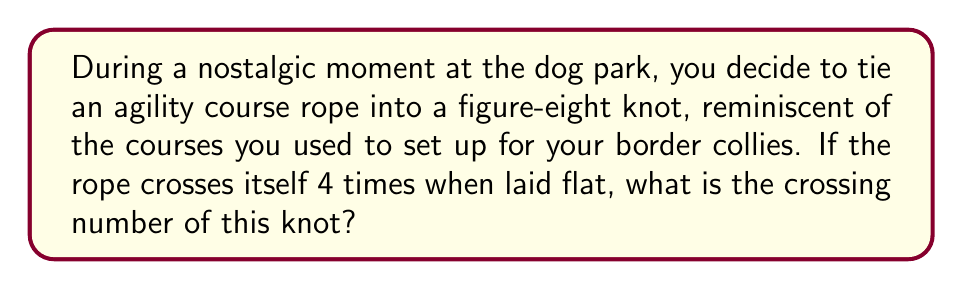Could you help me with this problem? To determine the crossing number of the knot formed by the agility course rope, we need to follow these steps:

1. Recognize the knot type:
   The description of a figure-eight knot with 4 crossings when laid flat suggests we're dealing with the standard figure-eight knot, also known as the 4₁ knot in knot theory.

2. Understand the concept of crossing number:
   The crossing number of a knot is defined as the minimum number of crossings in any diagram of the knot. It's denoted by $c(K)$ where $K$ is the knot.

3. Analyze the given information:
   We're told that the rope crosses itself 4 times when laid flat. This is actually the minimal number of crossings for a figure-eight knot.

4. Consider potential simplifications:
   In knot theory, we always look for the diagram with the least number of crossings. For the figure-eight knot, it's proven that 4 crossings is the minimum possible.

5. Conclude:
   Since 4 is the minimum number of crossings for any diagram of the figure-eight knot, this is indeed its crossing number.

Mathematically, we can express this as:

$$c(4_1) = 4$$

Where $4_1$ represents the figure-eight knot in standard notation.
Answer: 4 